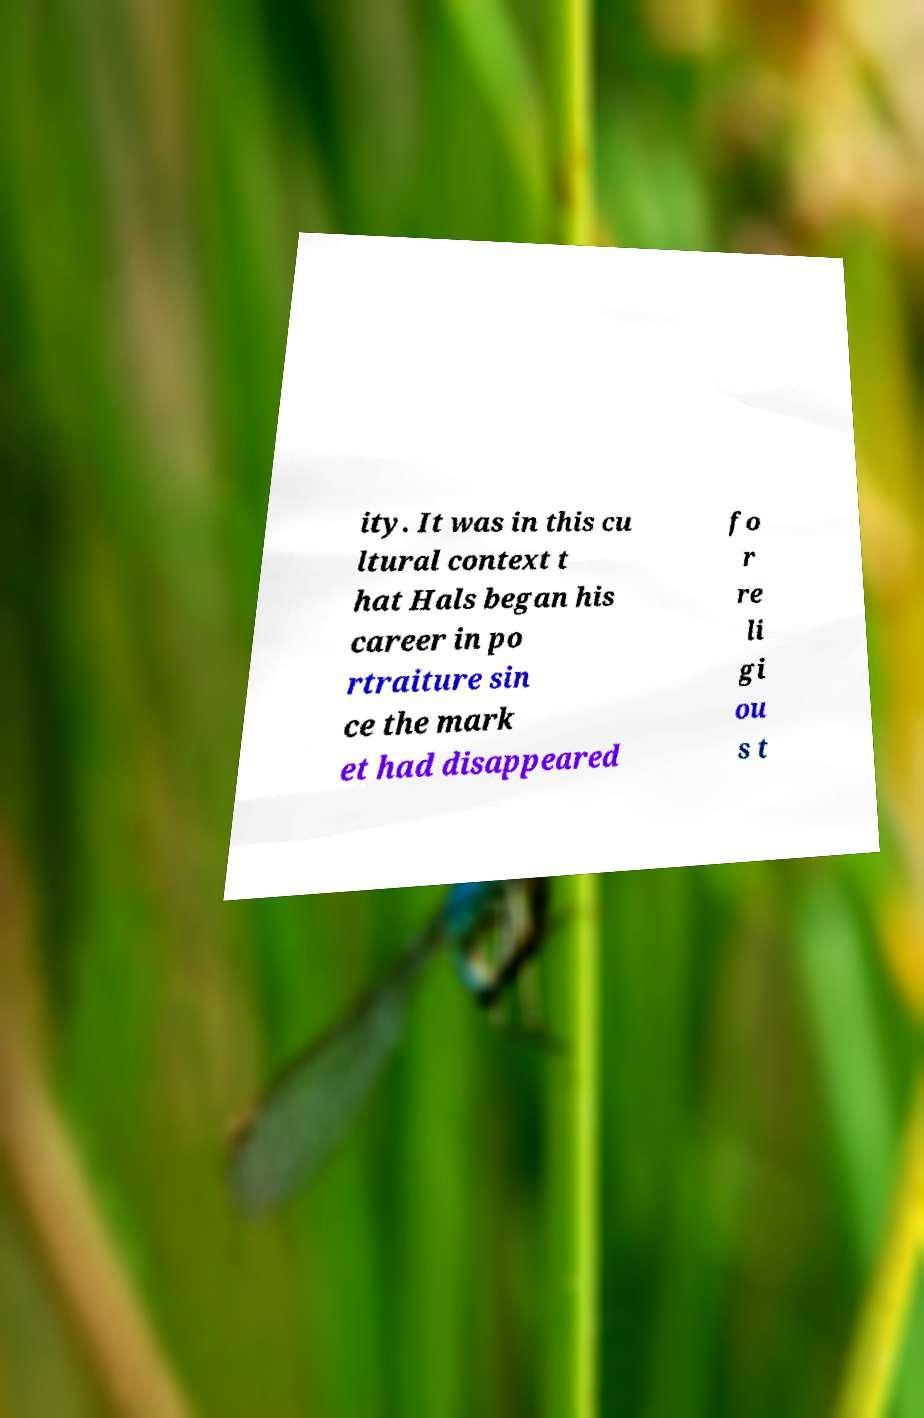Please identify and transcribe the text found in this image. ity. It was in this cu ltural context t hat Hals began his career in po rtraiture sin ce the mark et had disappeared fo r re li gi ou s t 